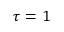<formula> <loc_0><loc_0><loc_500><loc_500>\tau = 1</formula> 